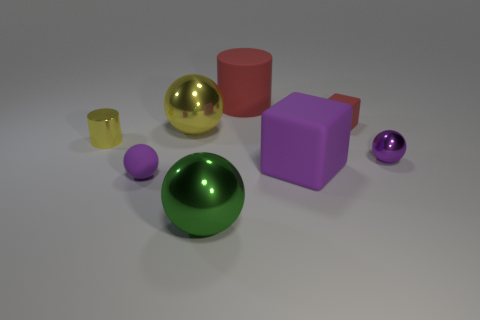Add 1 tiny cylinders. How many objects exist? 9 Subtract all cylinders. How many objects are left? 6 Add 1 large purple metal balls. How many large purple metal balls exist? 1 Subtract 1 red cylinders. How many objects are left? 7 Subtract all big yellow metal things. Subtract all large red cylinders. How many objects are left? 6 Add 3 metal things. How many metal things are left? 7 